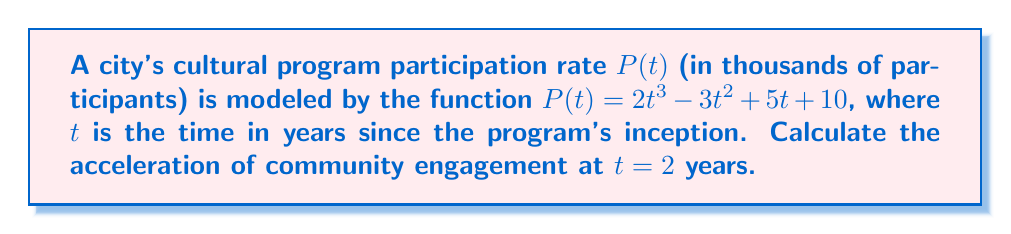Could you help me with this problem? To find the acceleration of community engagement, we need to calculate the second derivative of the participation function $P(t)$ and evaluate it at $t = 2$.

Step 1: Find the first derivative (velocity of engagement)
$$\frac{dP}{dt} = P'(t) = 6t^2 - 6t + 5$$

Step 2: Find the second derivative (acceleration of engagement)
$$\frac{d^2P}{dt^2} = P''(t) = 12t - 6$$

Step 3: Evaluate the second derivative at $t = 2$
$$P''(2) = 12(2) - 6 = 24 - 6 = 18$$

The acceleration of community engagement at $t = 2$ years is 18 thousand participants per year squared.
Answer: $18$ thousand/year² 